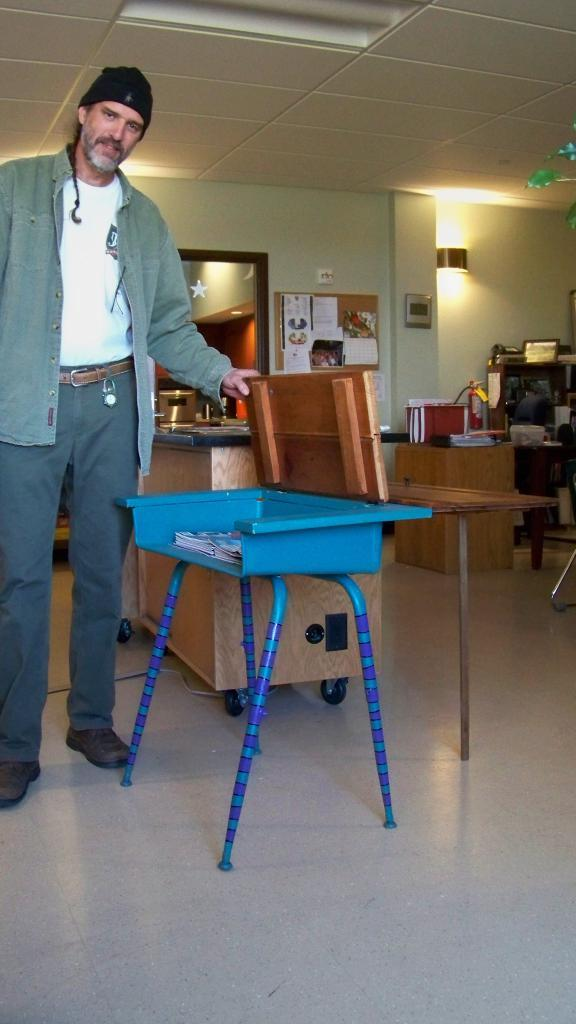What is the main subject of the image? There is a man in the image. What is the man doing in the image? The man is standing in the image. What object is the man holding in the image? The man is holding the upper part of a study table. What type of drum is the man playing in the image? There is no drum present in the image; the man is holding the upper part of a study table. Can you tell me the relationship between the man and the person in the image? There is no other person present in the image, so it is not possible to determine the man's relationship with anyone. 